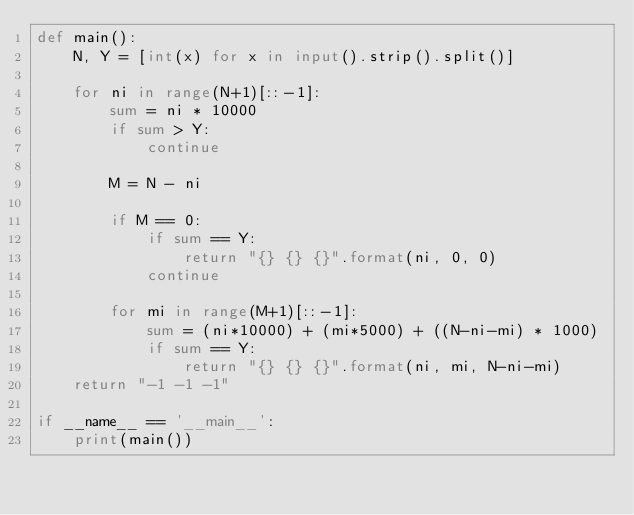Convert code to text. <code><loc_0><loc_0><loc_500><loc_500><_Python_>def main():
    N, Y = [int(x) for x in input().strip().split()]
    
    for ni in range(N+1)[::-1]:
        sum = ni * 10000
        if sum > Y:
            continue

        M = N - ni

        if M == 0:
            if sum == Y:
                return "{} {} {}".format(ni, 0, 0)
            continue

        for mi in range(M+1)[::-1]:
            sum = (ni*10000) + (mi*5000) + ((N-ni-mi) * 1000)
            if sum == Y:
                return "{} {} {}".format(ni, mi, N-ni-mi)
    return "-1 -1 -1"
    
if __name__ == '__main__':
    print(main())</code> 